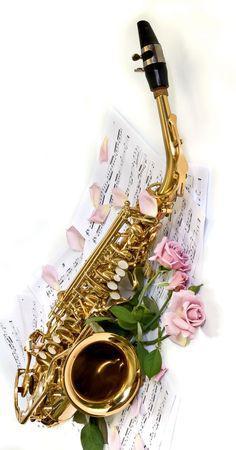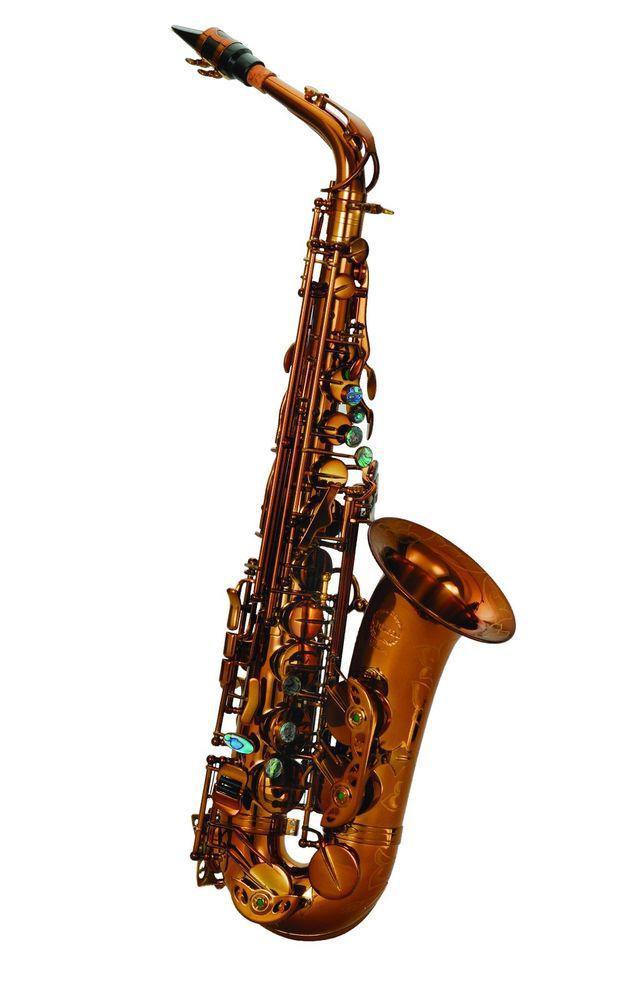The first image is the image on the left, the second image is the image on the right. For the images displayed, is the sentence "In at least one image there is a single saxophone surrounded by purple special dots." factually correct? Answer yes or no. No. The first image is the image on the left, the second image is the image on the right. Considering the images on both sides, is "The sax in the left image is pointed left and the sax in the right image is pointed right." valid? Answer yes or no. No. 